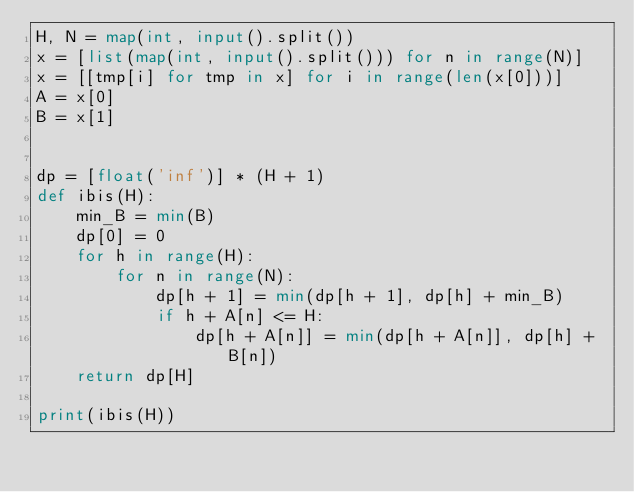Convert code to text. <code><loc_0><loc_0><loc_500><loc_500><_Python_>H, N = map(int, input().split())
x = [list(map(int, input().split())) for n in range(N)]
x = [[tmp[i] for tmp in x] for i in range(len(x[0]))]
A = x[0]
B = x[1]


dp = [float('inf')] * (H + 1)
def ibis(H):
    min_B = min(B)
    dp[0] = 0
    for h in range(H):
        for n in range(N):
            dp[h + 1] = min(dp[h + 1], dp[h] + min_B)
            if h + A[n] <= H:
                dp[h + A[n]] = min(dp[h + A[n]], dp[h] + B[n])
    return dp[H]

print(ibis(H))</code> 